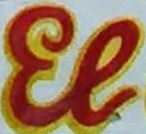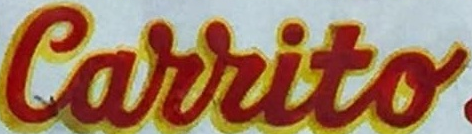What words can you see in these images in sequence, separated by a semicolon? El; Carrito 